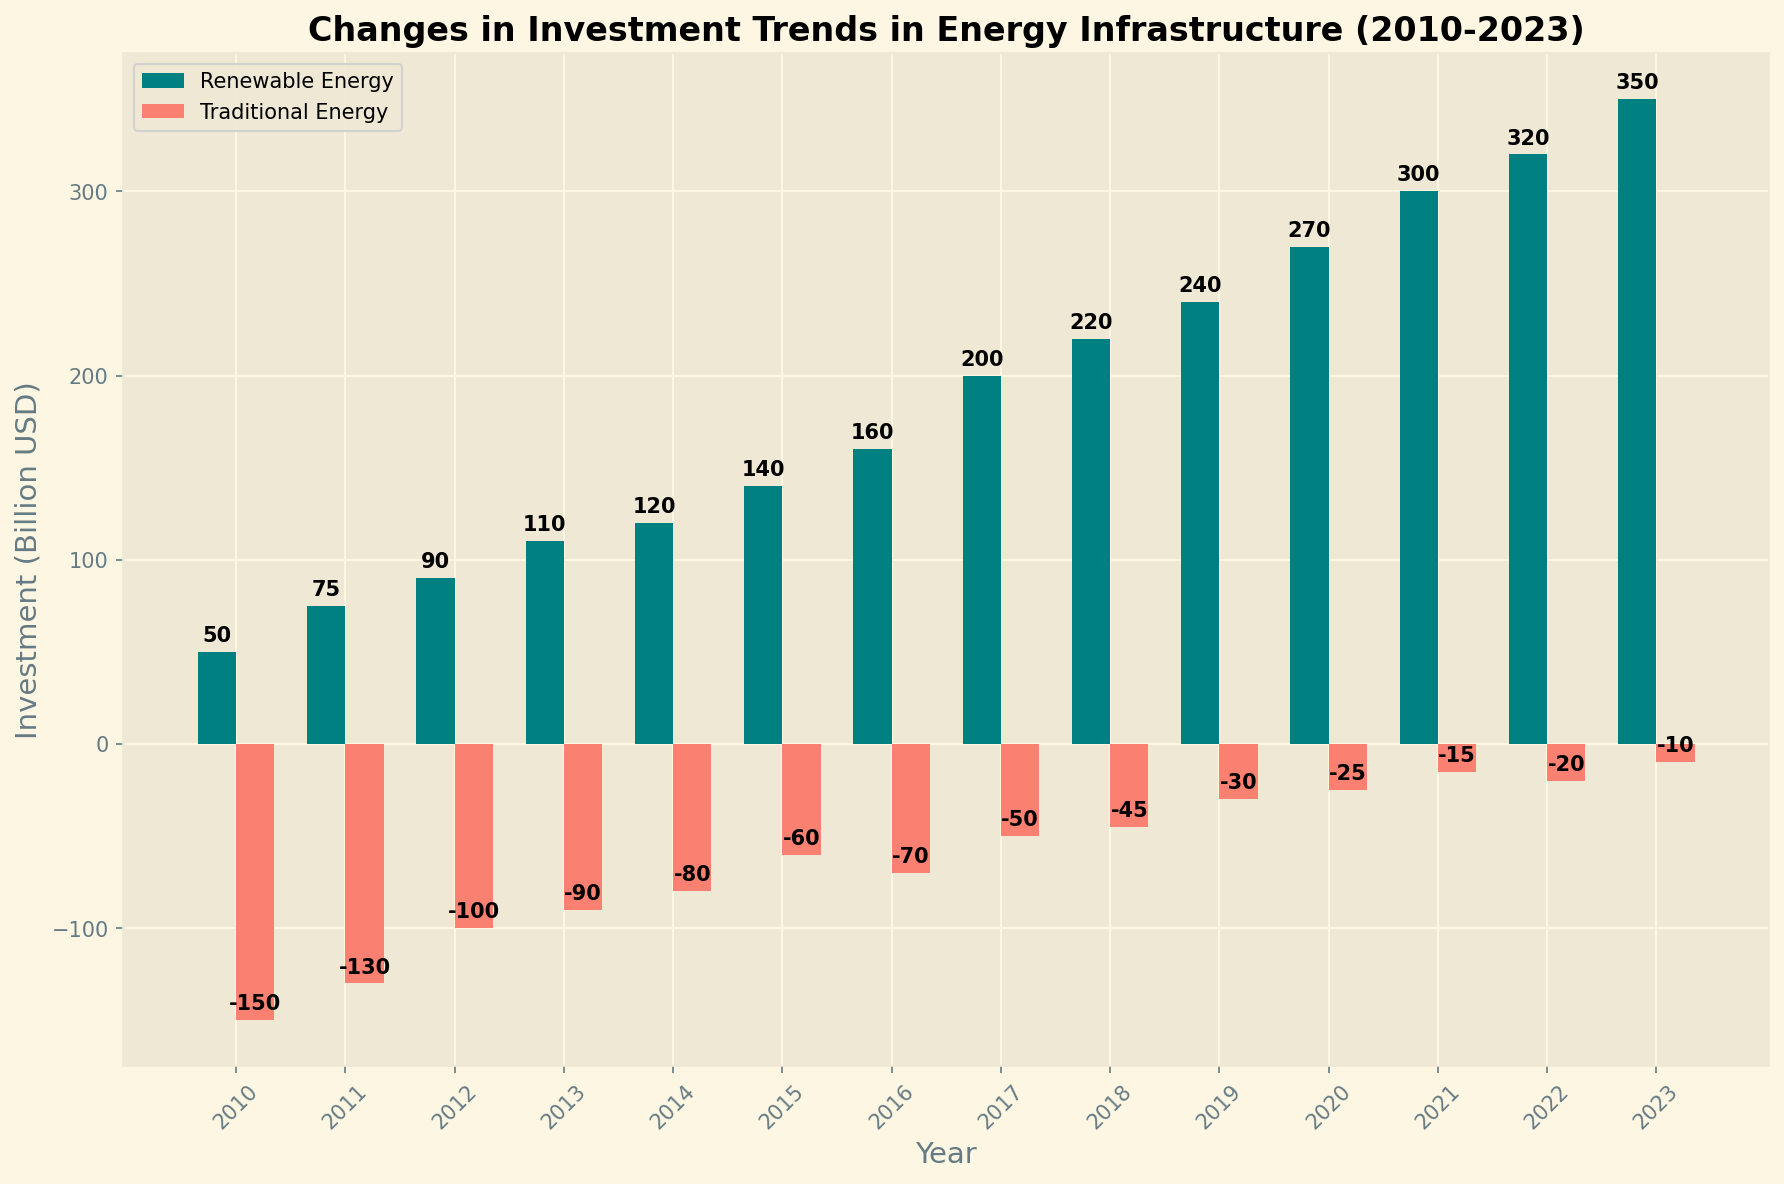What trend can be observed in renewable energy investment from 2010 to 2023? The bar chart shows a steady increase in renewable energy investment from 50 billion USD in 2010 to 350 billion USD in 2023.
Answer: steady increase How did traditional energy investment change from 2010 to 2023? Traditional energy investment decreased over the years, starting from -150 billion USD in 2010 and reaching -10 billion USD in 2023.
Answer: steady decrease In which year were investments in renewable energy 15 billion USD more than in the previous year? From the chart, the investment in renewable energy increases by 15 billion USD between 2011 (75 billion USD) and 2012 (90 billion USD).
Answer: 2012 Which year had the highest negative investment in traditional energy? The highest negative investment in traditional energy is seen in 2010, with -150 billion USD.
Answer: 2010 Compare the investment trends between renewable and traditional energy in 2017. In 2017, the investment in renewable energy was 200 billion USD, while traditional energy had a negative investment of -50 billion USD.
Answer: Renewable > Traditional How much more investment was made in renewable energy compared to traditional energy in 2021? In 2021, renewable energy investment was 300 billion USD and traditional energy investment was -15 billion USD. The difference is 300 - (-15) = 315 billion USD.
Answer: 315 billion USD Which years show a simultaneous increase in investment for renewable energy and decrease in traditional energy? The years that show an increase in renewable energy investment and a decrease in traditional energy investment are 2011, 2012, 2014, and 2023.
Answer: 2011, 2012, 2014, 2023 What year saw the smallest difference between investments in renewable and traditional energy? The smallest difference can be observed in 2023: 350 billion USD in renewable energy and -10 billion USD in traditional energy, a difference of 360 billion USD.
Answer: 2023 In what year did renewable energy investment first exceed 200 billion USD? Renewable energy investment first exceeded 200 billion USD in the year 2018, where the investment was 220 billion USD.
Answer: 2018 What can be inferred about the trends in fossil fuel versus renewable energy investment over this period? Over the period from 2010 to 2023, investment in traditional (fossil fuel) energy steadily decreased while investment in renewable energy substantially increased, indicating a shift towards renewable energy sources.
Answer: Shift towards renewables 